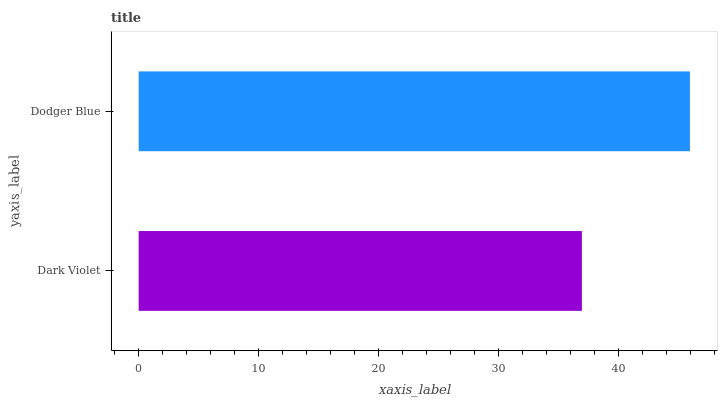Is Dark Violet the minimum?
Answer yes or no. Yes. Is Dodger Blue the maximum?
Answer yes or no. Yes. Is Dodger Blue the minimum?
Answer yes or no. No. Is Dodger Blue greater than Dark Violet?
Answer yes or no. Yes. Is Dark Violet less than Dodger Blue?
Answer yes or no. Yes. Is Dark Violet greater than Dodger Blue?
Answer yes or no. No. Is Dodger Blue less than Dark Violet?
Answer yes or no. No. Is Dodger Blue the high median?
Answer yes or no. Yes. Is Dark Violet the low median?
Answer yes or no. Yes. Is Dark Violet the high median?
Answer yes or no. No. Is Dodger Blue the low median?
Answer yes or no. No. 